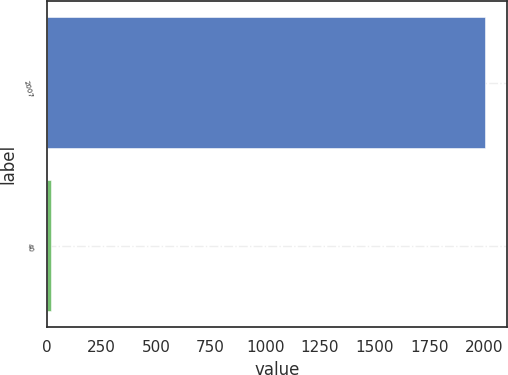Convert chart to OTSL. <chart><loc_0><loc_0><loc_500><loc_500><bar_chart><fcel>2007<fcel>40<nl><fcel>2005<fcel>21<nl></chart> 